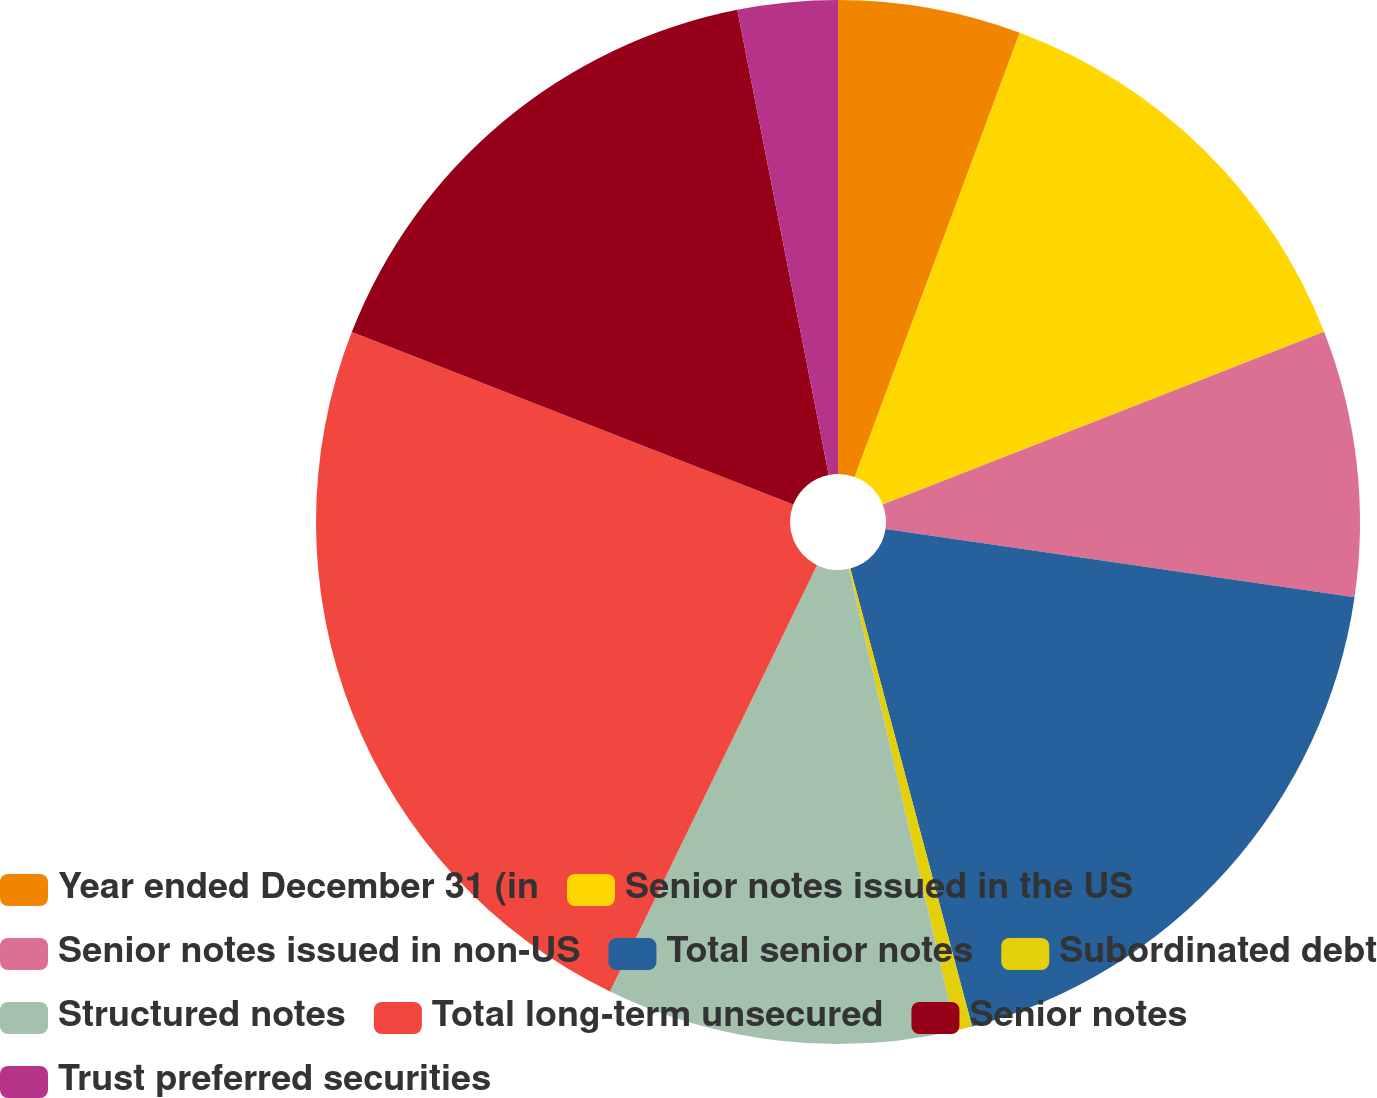Convert chart to OTSL. <chart><loc_0><loc_0><loc_500><loc_500><pie_chart><fcel>Year ended December 31 (in<fcel>Senior notes issued in the US<fcel>Senior notes issued in non-US<fcel>Total senior notes<fcel>Subordinated debt<fcel>Structured notes<fcel>Total long-term unsecured<fcel>Senior notes<fcel>Trust preferred securities<nl><fcel>5.66%<fcel>13.4%<fcel>8.24%<fcel>18.56%<fcel>0.51%<fcel>10.82%<fcel>23.73%<fcel>15.98%<fcel>3.09%<nl></chart> 